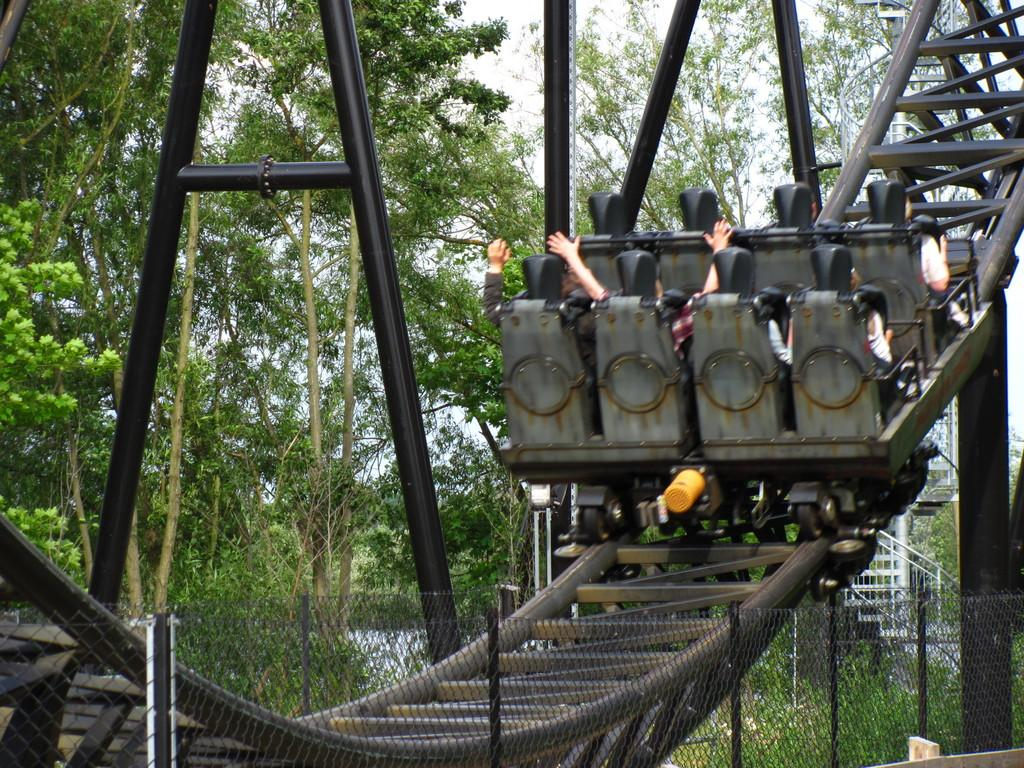What is the main feature of the picture? There is a rollercoaster hump in the picture. Are there any people in the picture? Yes, there are people sitting in the roller coaster. What can be seen in the background of the picture? There are trees and the sky visible in the background of the picture. What type of discussion is taking place in the roller coaster in the image? There is no discussion taking place in the roller coaster in the image; it is a still picture of people sitting in the roller coaster. 